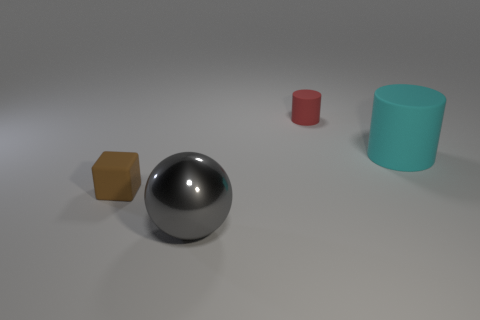Add 1 tiny green matte objects. How many objects exist? 5 Subtract all cubes. How many objects are left? 3 Subtract 1 cylinders. How many cylinders are left? 1 Subtract all red cubes. Subtract all purple cylinders. How many cubes are left? 1 Add 1 brown cubes. How many brown cubes are left? 2 Add 4 big gray metal things. How many big gray metal things exist? 5 Subtract 0 green cubes. How many objects are left? 4 Subtract all small red cylinders. Subtract all big gray shiny balls. How many objects are left? 2 